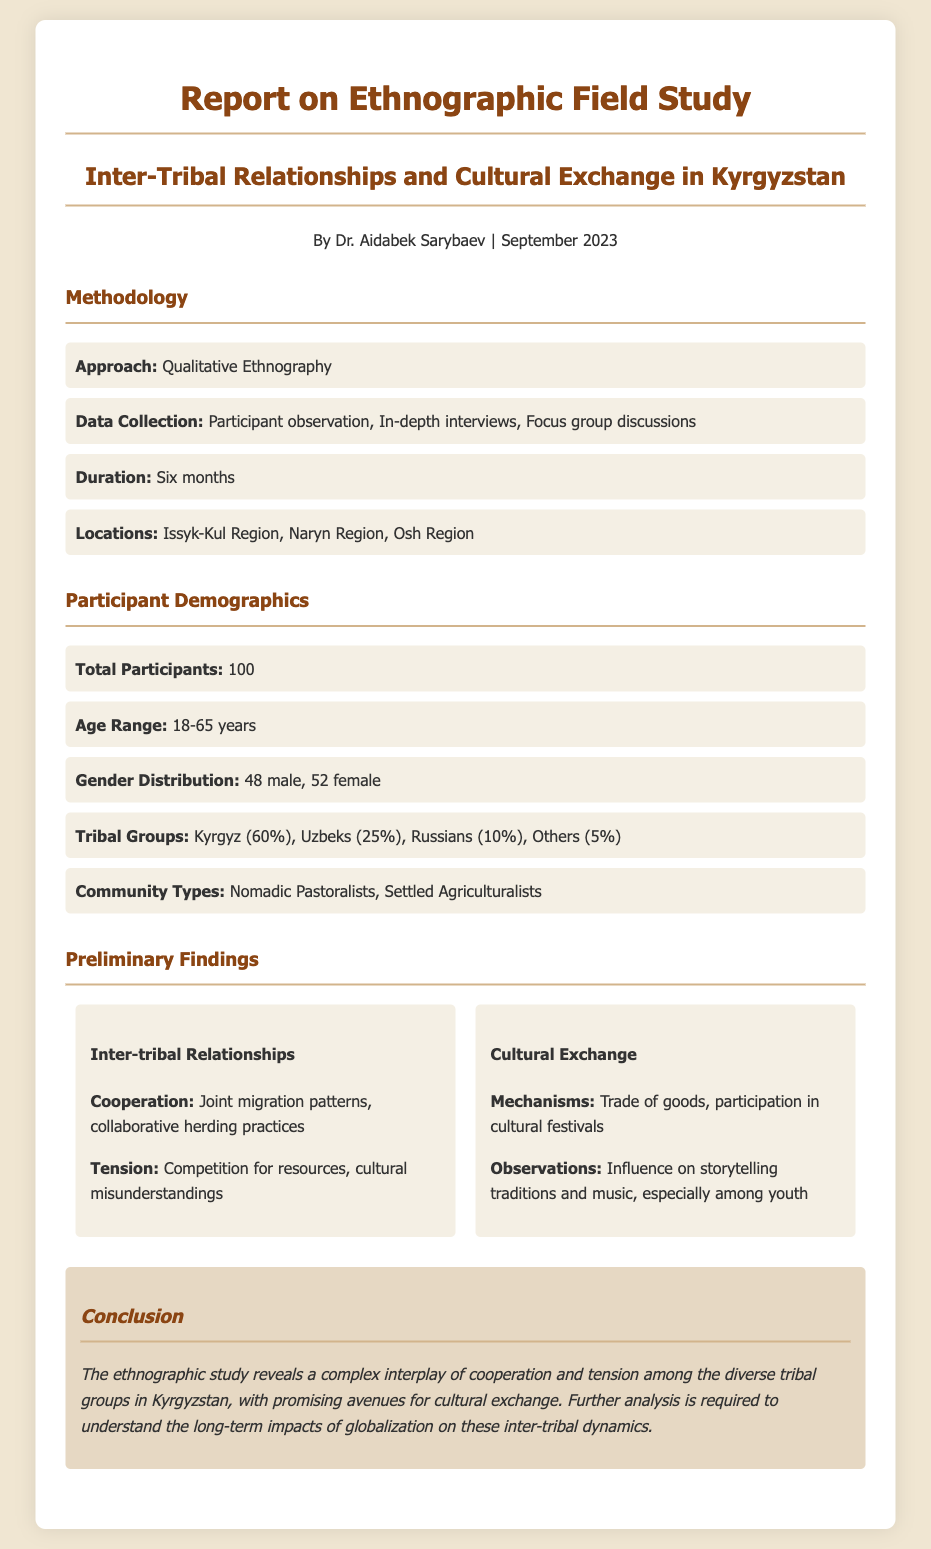what is the title of the report? The title of the report is listed at the top of the document under the header section.
Answer: Report on Ethnographic Field Study who conducted the ethnographic study? The author of the study is mentioned in the introduction along with their credentials.
Answer: Dr. Aidabek Sarybaev how long was the field study conducted? The duration of the study is specified in the methodology section.
Answer: Six months what is the age range of the participants? The age range of the participants is mentioned in the demographics section.
Answer: 18-65 years what percentage of participants were Kyrgyz? The percentage of participants from different tribal groups is provided in the demographics section.
Answer: 60% what mechanisms of cultural exchange were observed? Mechanisms of cultural exchange are listed in the findings section under cultural exchange.
Answer: Trade of goods, participation in cultural festivals what tension was noted in inter-tribal relationships? The findings section details the types of tensions observed during the study.
Answer: Competition for resources, cultural misunderstandings what is a promising avenue for cultural exchange identified in the report? The conclusion highlights areas for further exploration related to cultural exchange.
Answer: Cultural exchange how many total participants were involved in the study? The total number of participants is indicated in the demographics section.
Answer: 100 